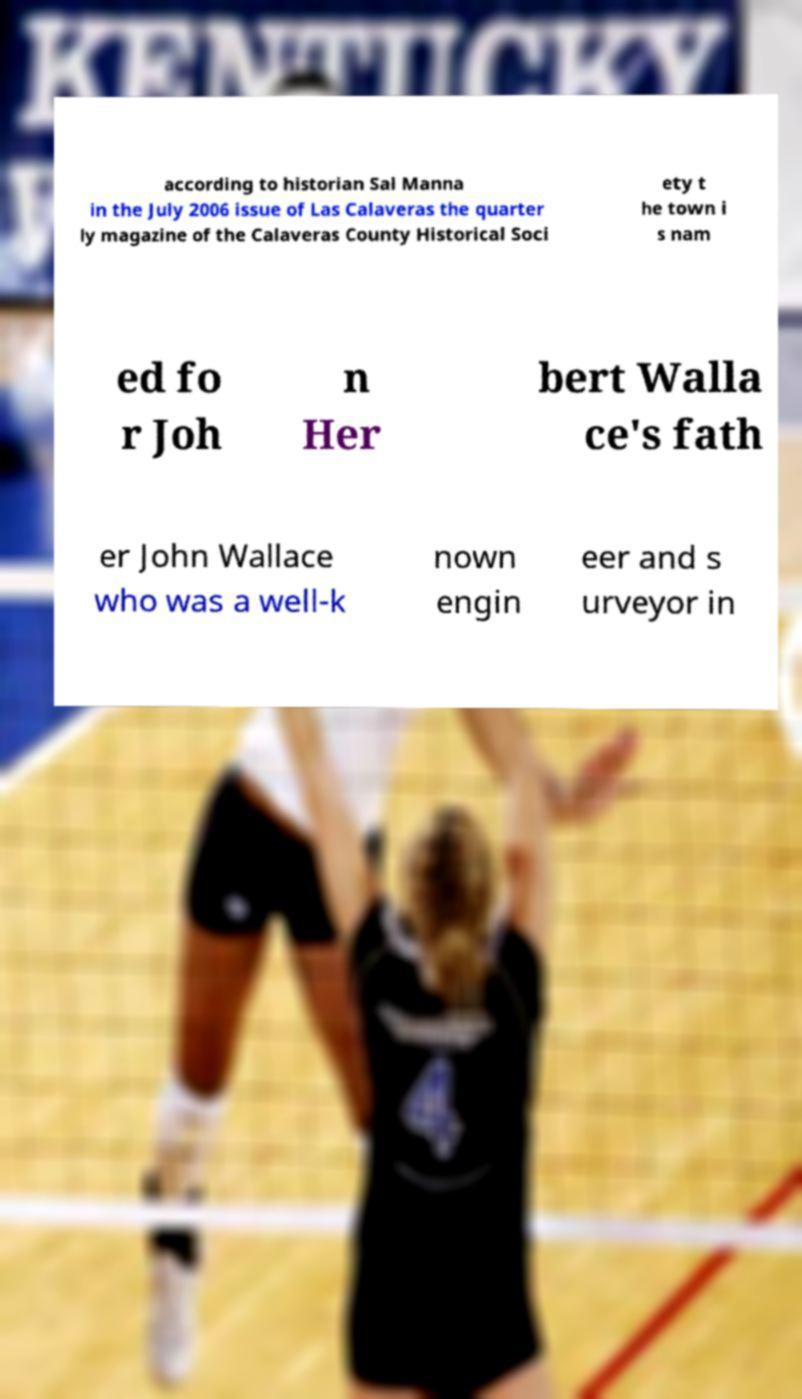What messages or text are displayed in this image? I need them in a readable, typed format. according to historian Sal Manna in the July 2006 issue of Las Calaveras the quarter ly magazine of the Calaveras County Historical Soci ety t he town i s nam ed fo r Joh n Her bert Walla ce's fath er John Wallace who was a well-k nown engin eer and s urveyor in 